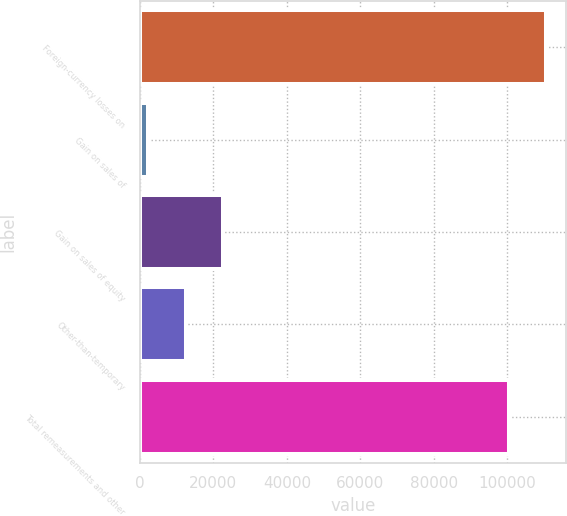Convert chart. <chart><loc_0><loc_0><loc_500><loc_500><bar_chart><fcel>Foreign-currency losses on<fcel>Gain on sales of<fcel>Gain on sales of equity<fcel>Other-than-temporary<fcel>Total remeasurements and other<nl><fcel>110533<fcel>2227<fcel>22667.9<fcel>12577<fcel>100442<nl></chart> 